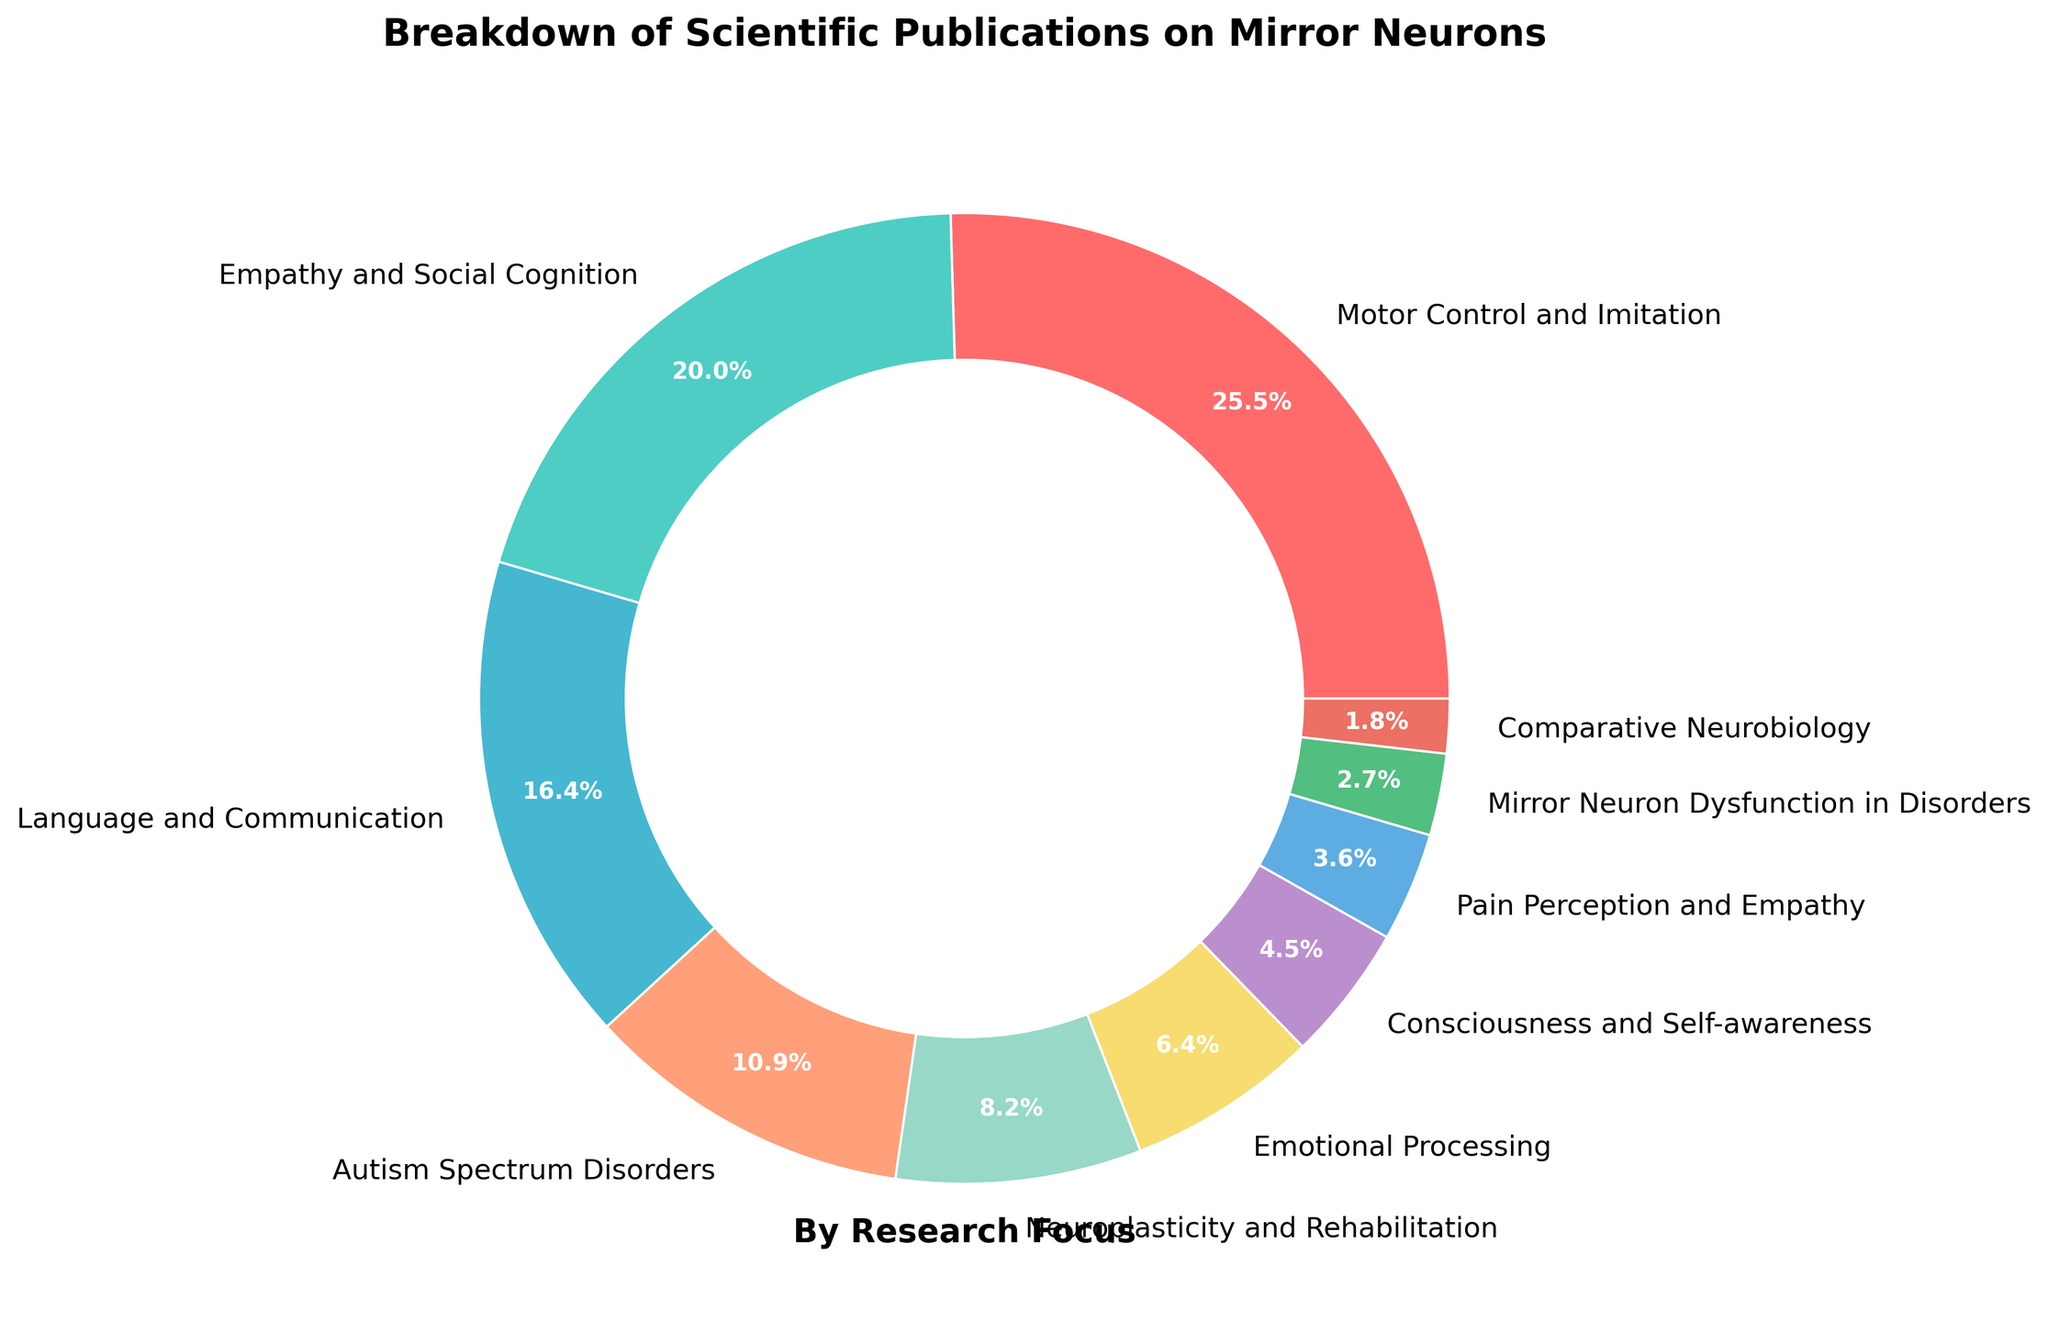What percentage of publications focus on Language and Communication? Locate the "Language and Communication" label on the pie chart. The percentage is directly indicated near this segment.
Answer: 18% Which research focus has the least percentage of publications? To find the research focus with the least percentage, look for the smallest segment in the pie chart. The percentage and label will tell you the answer.
Answer: Comparative Neurobiology What is the combined percentage of publications focusing on Autism Spectrum Disorders and Mirror Neuron Dysfunction in Disorders? Find the percentages for "Autism Spectrum Disorders" and "Mirror Neuron Dysfunction in Disorders," which are 12% and 3%, respectively. Sum these percentages: 12% + 3% = 15%.
Answer: 15% Which is higher, the percentage of publications on Motor Control and Imitation or on Empathy and Social Cognition? Compare the percentages indicated on the pie chart for "Motor Control and Imitation" (28%) and "Empathy and Social Cognition" (22%).
Answer: Motor Control and Imitation Which segment in the chart has a green color, and what is its research focus? Identify the segment with a green color. It corresponds to the research focus label closest to this segment.
Answer: Empathy and Social Cognition Do publications on Neuroplasticity and Rehabilitation have a higher percentage than those on Emotional Processing? Compare the percentages for "Neuroplasticity and Rehabilitation" (9%) and "Emotional Processing" (7%) from the chart.
Answer: Yes What is the difference in publication percentage between Consciousness and Self-awareness and Pain Perception and Empathy? Locate the percentages for "Consciousness and Self-awareness" (5%) and "Pain Perception and Empathy" (4%) on the pie chart. Subtract to find the difference: 5% - 4% = 1%.
Answer: 1% How many research focuses have a percentage greater than 10%? Count the segments in the pie chart with percentages above 10%. These are "Motor Control and Imitation" (28%), "Empathy and Social Cognition" (22%), "Language and Communication" (18%), and "Autism Spectrum Disorders" (12%).
Answer: 4 Among the listed focuses, which one has a purple color, and what is its corresponding percentage? Locate the purple segment in the pie chart. The label and percentage next to it will provide the answer.
Answer: Consciousness and Self-awareness, 5% 